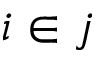Convert formula to latex. <formula><loc_0><loc_0><loc_500><loc_500>i \in j</formula> 